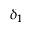<formula> <loc_0><loc_0><loc_500><loc_500>\delta _ { 1 }</formula> 